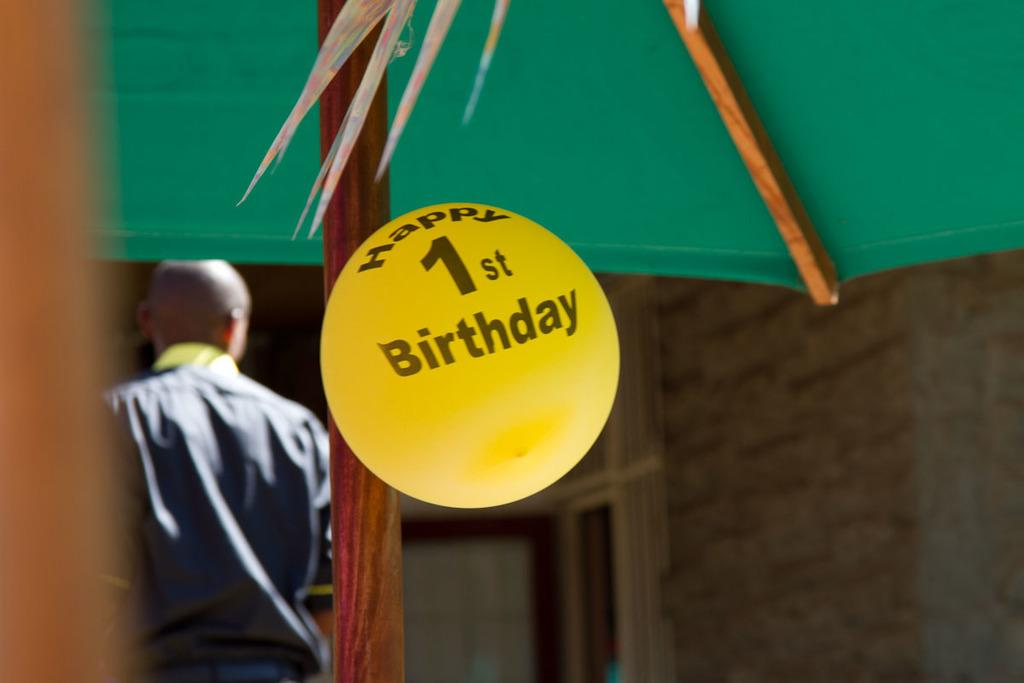What structure can be seen in the image? There is a tent in the image. Who or what is inside the tent? There is a person in the image. What type of natural elements are present in the image? Leaves are present in the image. What additional object can be seen in the image? There is a balloon in the image. What is written on the balloon? The balloon has text on it. What can be seen in the background of the image? There is a wall and windows in the background of the image. What type of chin can be seen on the person in the image? There is no chin visible in the image; only a person's body is shown. How many needles are attached to the balloon in the image? There are no needles present in the image; only a balloon with text is visible. 